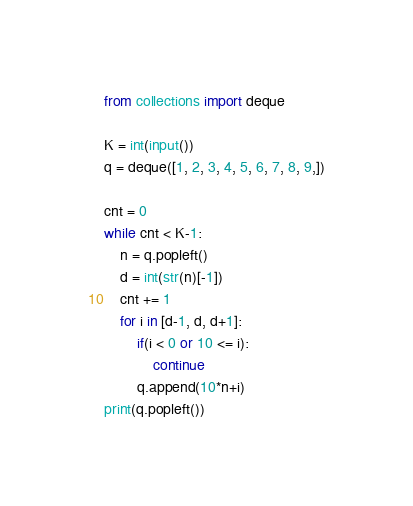<code> <loc_0><loc_0><loc_500><loc_500><_Python_>from collections import deque

K = int(input())
q = deque([1, 2, 3, 4, 5, 6, 7, 8, 9,])

cnt = 0
while cnt < K-1:
    n = q.popleft()
    d = int(str(n)[-1])
    cnt += 1
    for i in [d-1, d, d+1]:
        if(i < 0 or 10 <= i):
            continue
        q.append(10*n+i)
print(q.popleft())</code> 